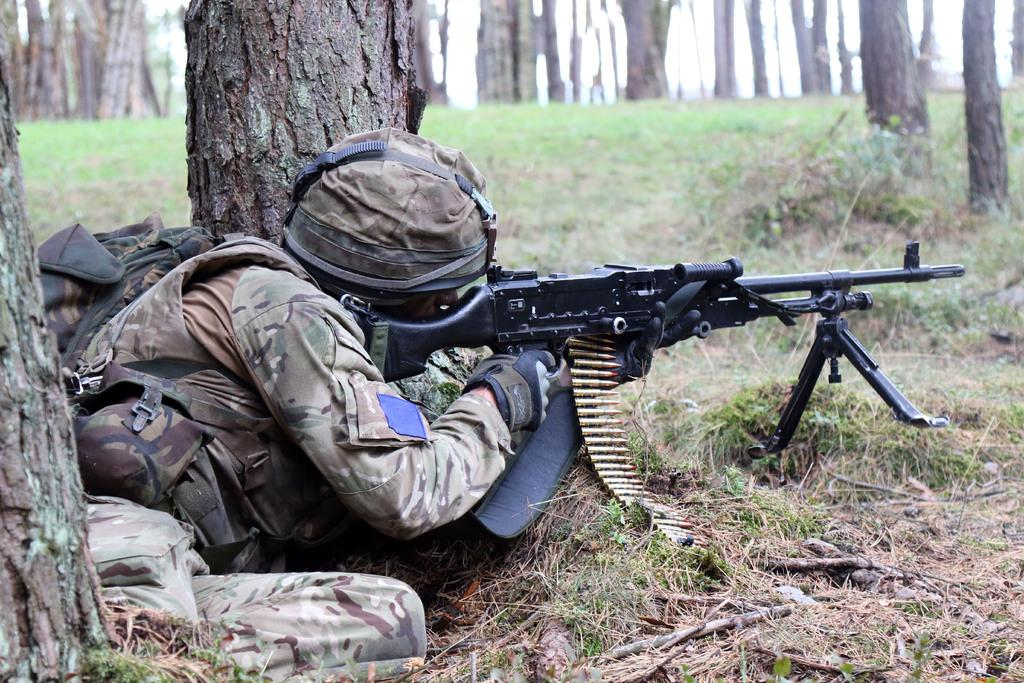What type of vegetation can be seen in the image? There is grass in the image. What is the soldier doing in the image? The soldier is laying on the floor and targeting with a gun. What can be seen in the background of the image? There are trees around the soldier. What type of drug is the soldier using to increase his accuracy in the image? There is no indication of any drug use in the image. What is the soldier's profit margin for each target hit in the image? There is no information about profit in the image. 